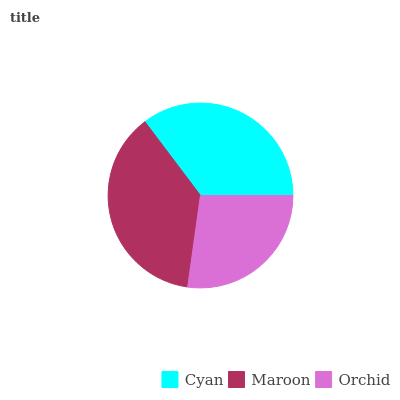Is Orchid the minimum?
Answer yes or no. Yes. Is Maroon the maximum?
Answer yes or no. Yes. Is Maroon the minimum?
Answer yes or no. No. Is Orchid the maximum?
Answer yes or no. No. Is Maroon greater than Orchid?
Answer yes or no. Yes. Is Orchid less than Maroon?
Answer yes or no. Yes. Is Orchid greater than Maroon?
Answer yes or no. No. Is Maroon less than Orchid?
Answer yes or no. No. Is Cyan the high median?
Answer yes or no. Yes. Is Cyan the low median?
Answer yes or no. Yes. Is Maroon the high median?
Answer yes or no. No. Is Orchid the low median?
Answer yes or no. No. 